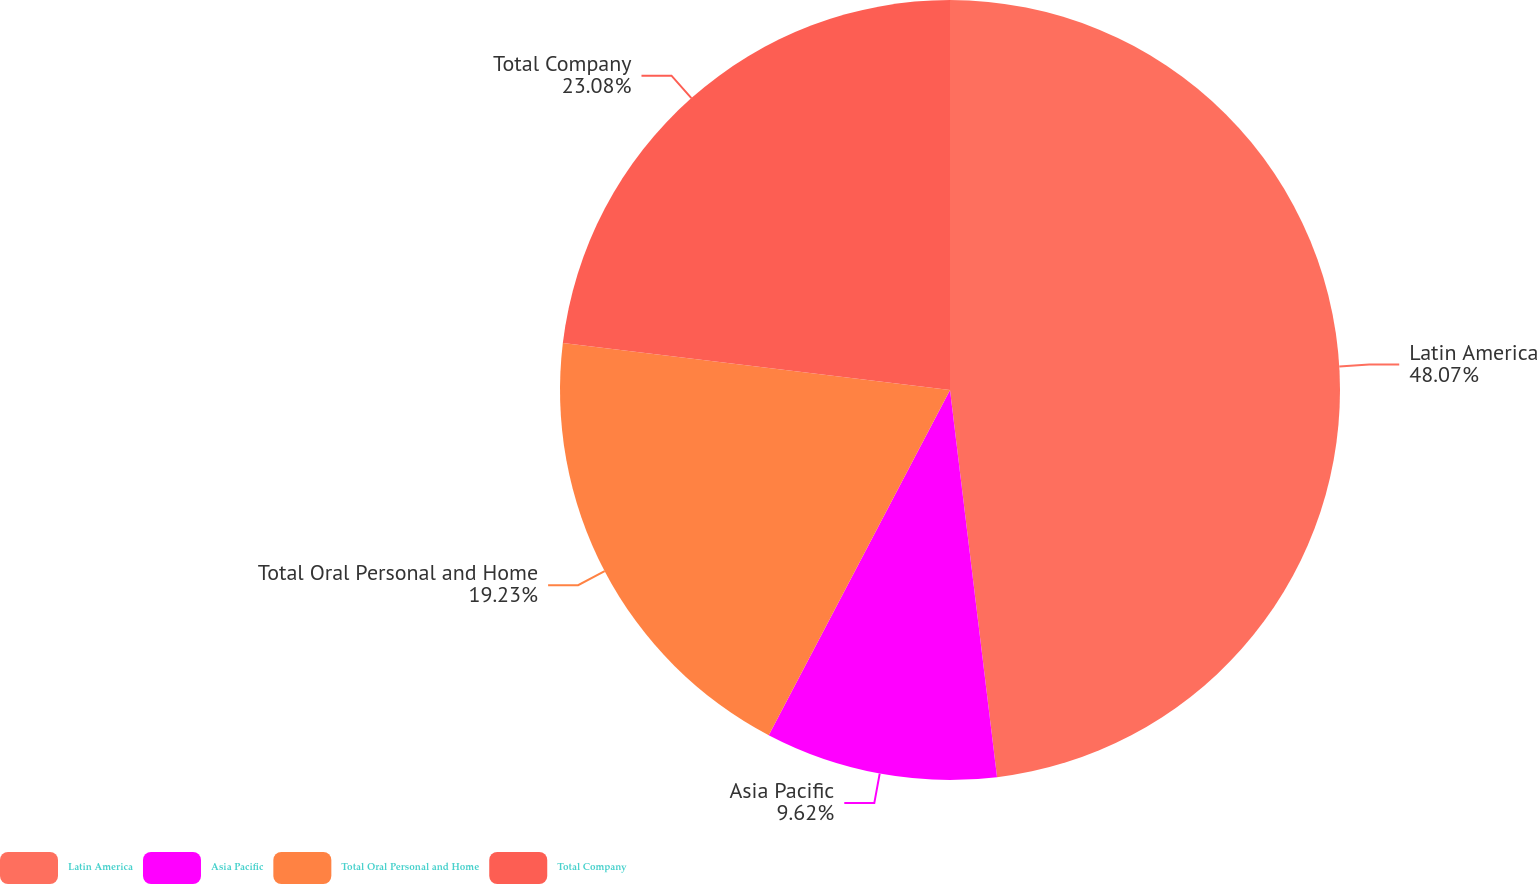Convert chart to OTSL. <chart><loc_0><loc_0><loc_500><loc_500><pie_chart><fcel>Latin America<fcel>Asia Pacific<fcel>Total Oral Personal and Home<fcel>Total Company<nl><fcel>48.08%<fcel>9.62%<fcel>19.23%<fcel>23.08%<nl></chart> 